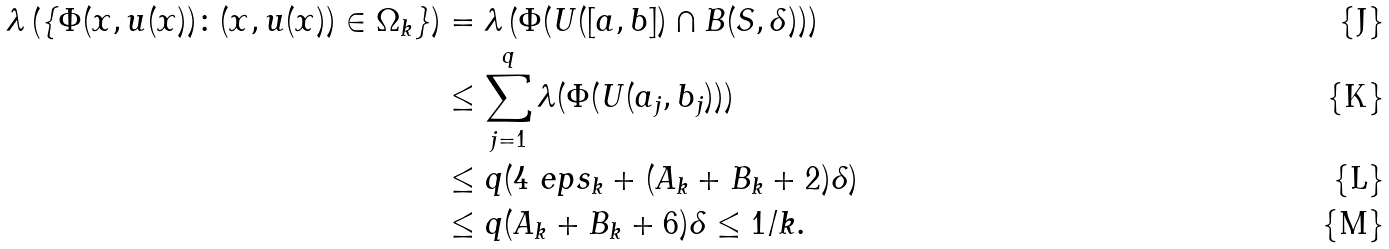<formula> <loc_0><loc_0><loc_500><loc_500>\lambda \left ( \{ \Phi ( x , u ( x ) ) \colon ( x , u ( x ) ) \in \Omega _ { k } \} \right ) & = \lambda \left ( \Phi ( U ( [ a , b ] ) \cap B ( S , \delta ) ) \right ) \\ & \leq \sum _ { j = 1 } ^ { q } \lambda ( \Phi ( U ( a _ { j } , b _ { j } ) ) ) \\ & \leq q ( 4 \ e p s _ { k } + ( A _ { k } + B _ { k } + 2 ) \delta ) \\ & \leq q ( A _ { k } + B _ { k } + 6 ) \delta \leq 1 / k .</formula> 